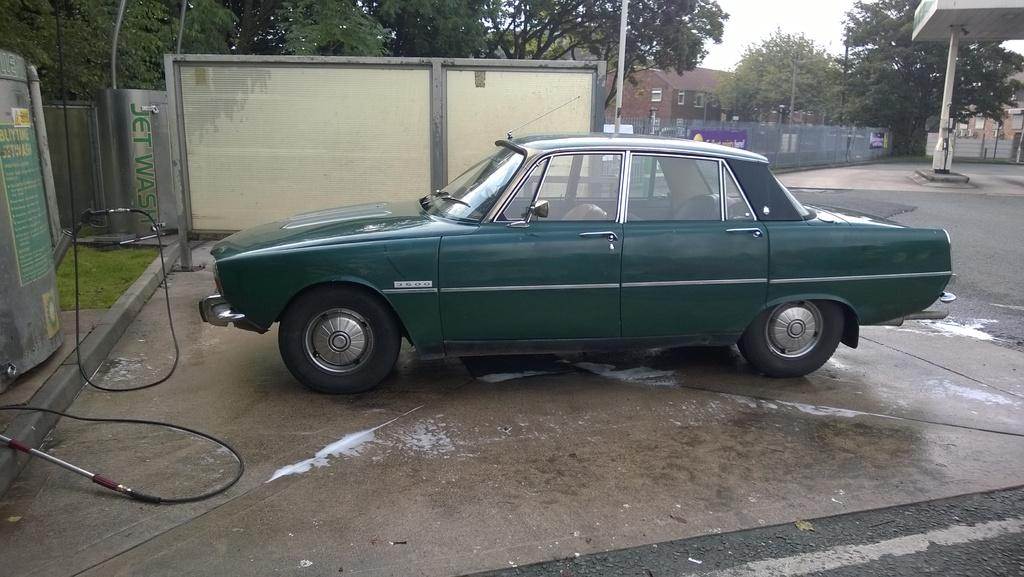What type of vehicle is in the image? There is a green car in the image. What can be seen on the left side of the image? There are trees on the left side of the image. What structures are located in the middle of the image? There are houses in the middle of the image. How much does the ghost cost in the image? There is no ghost present in the image, so it is not possible to determine its price. 